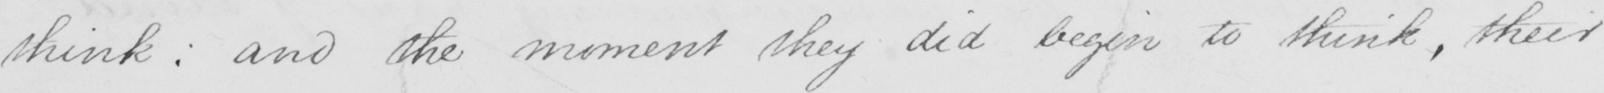Transcribe the text shown in this historical manuscript line. think :  and the moment they did begin to think , their 